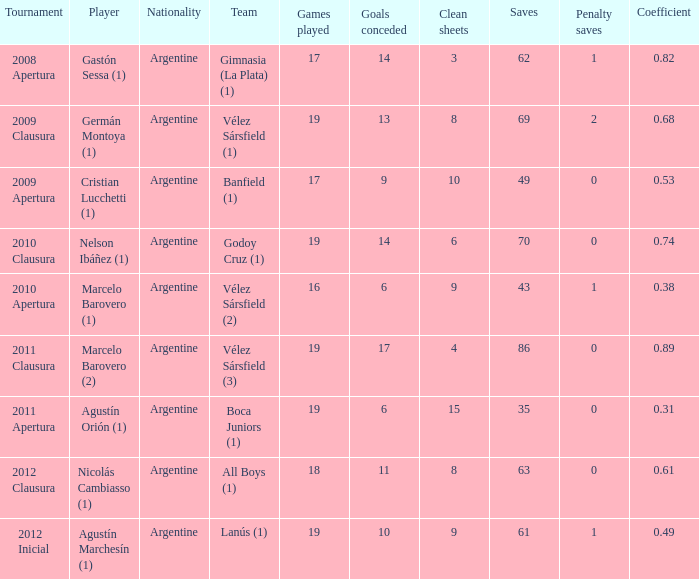What is the coefficient for agustín marchesín (1)? 0.49. 